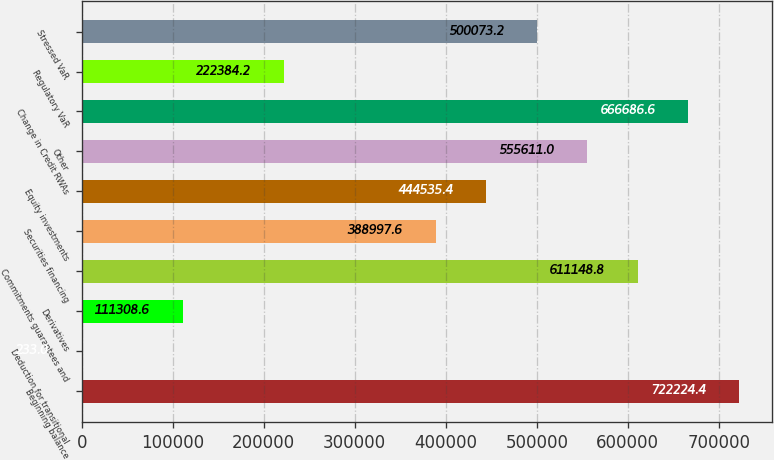Convert chart to OTSL. <chart><loc_0><loc_0><loc_500><loc_500><bar_chart><fcel>Beginning balance<fcel>Deduction for transitional<fcel>Derivatives<fcel>Commitments guarantees and<fcel>Securities financing<fcel>Equity investments<fcel>Other<fcel>Change in Credit RWAs<fcel>Regulatory VaR<fcel>Stressed VaR<nl><fcel>722224<fcel>233<fcel>111309<fcel>611149<fcel>388998<fcel>444535<fcel>555611<fcel>666687<fcel>222384<fcel>500073<nl></chart> 